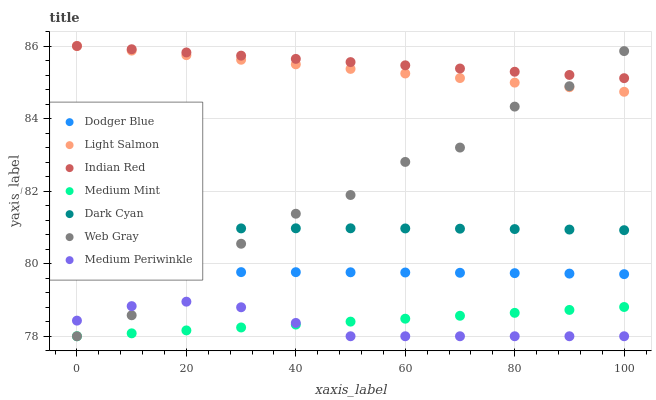Does Medium Periwinkle have the minimum area under the curve?
Answer yes or no. Yes. Does Indian Red have the maximum area under the curve?
Answer yes or no. Yes. Does Light Salmon have the minimum area under the curve?
Answer yes or no. No. Does Light Salmon have the maximum area under the curve?
Answer yes or no. No. Is Indian Red the smoothest?
Answer yes or no. Yes. Is Web Gray the roughest?
Answer yes or no. Yes. Is Light Salmon the smoothest?
Answer yes or no. No. Is Light Salmon the roughest?
Answer yes or no. No. Does Medium Mint have the lowest value?
Answer yes or no. Yes. Does Light Salmon have the lowest value?
Answer yes or no. No. Does Indian Red have the highest value?
Answer yes or no. Yes. Does Web Gray have the highest value?
Answer yes or no. No. Is Medium Mint less than Dodger Blue?
Answer yes or no. Yes. Is Light Salmon greater than Dark Cyan?
Answer yes or no. Yes. Does Web Gray intersect Light Salmon?
Answer yes or no. Yes. Is Web Gray less than Light Salmon?
Answer yes or no. No. Is Web Gray greater than Light Salmon?
Answer yes or no. No. Does Medium Mint intersect Dodger Blue?
Answer yes or no. No. 